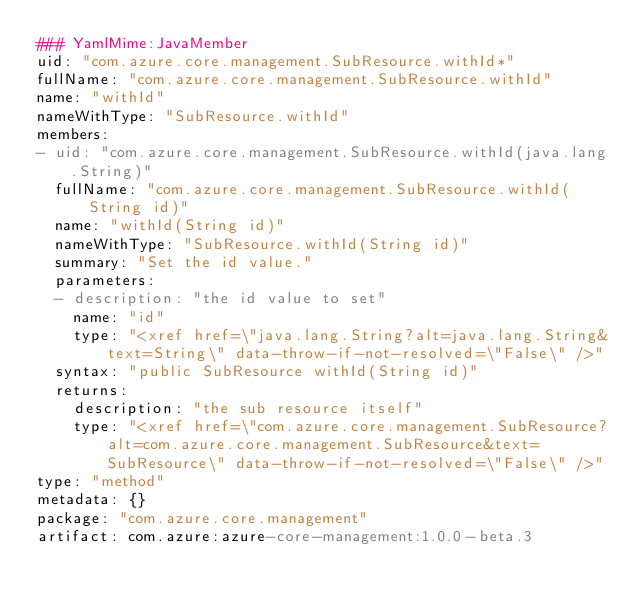Convert code to text. <code><loc_0><loc_0><loc_500><loc_500><_YAML_>### YamlMime:JavaMember
uid: "com.azure.core.management.SubResource.withId*"
fullName: "com.azure.core.management.SubResource.withId"
name: "withId"
nameWithType: "SubResource.withId"
members:
- uid: "com.azure.core.management.SubResource.withId(java.lang.String)"
  fullName: "com.azure.core.management.SubResource.withId(String id)"
  name: "withId(String id)"
  nameWithType: "SubResource.withId(String id)"
  summary: "Set the id value."
  parameters:
  - description: "the id value to set"
    name: "id"
    type: "<xref href=\"java.lang.String?alt=java.lang.String&text=String\" data-throw-if-not-resolved=\"False\" />"
  syntax: "public SubResource withId(String id)"
  returns:
    description: "the sub resource itself"
    type: "<xref href=\"com.azure.core.management.SubResource?alt=com.azure.core.management.SubResource&text=SubResource\" data-throw-if-not-resolved=\"False\" />"
type: "method"
metadata: {}
package: "com.azure.core.management"
artifact: com.azure:azure-core-management:1.0.0-beta.3
</code> 